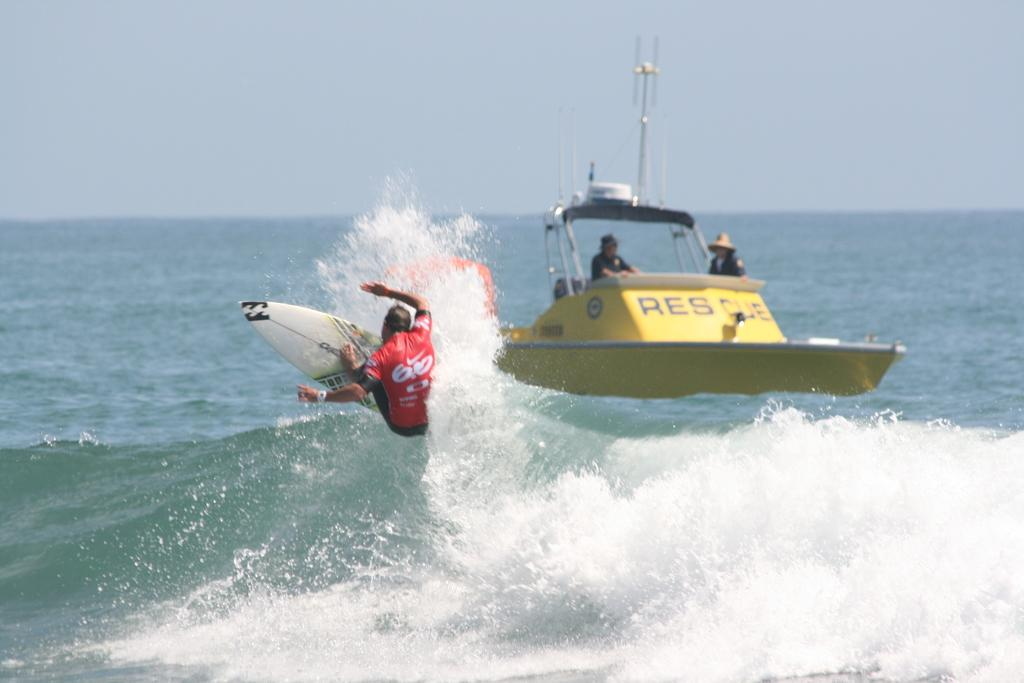Provide a one-sentence caption for the provided image. a boat on the water with thename like RESCA, but it's hard to read. 